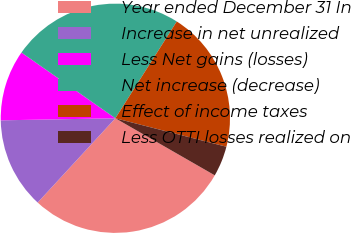<chart> <loc_0><loc_0><loc_500><loc_500><pie_chart><fcel>Year ended December 31 In<fcel>Increase in net unrealized<fcel>Less Net gains (losses)<fcel>Net increase (decrease)<fcel>Effect of income taxes<fcel>Less OTTI losses realized on<nl><fcel>28.56%<fcel>12.86%<fcel>10.01%<fcel>24.28%<fcel>20.0%<fcel>4.3%<nl></chart> 